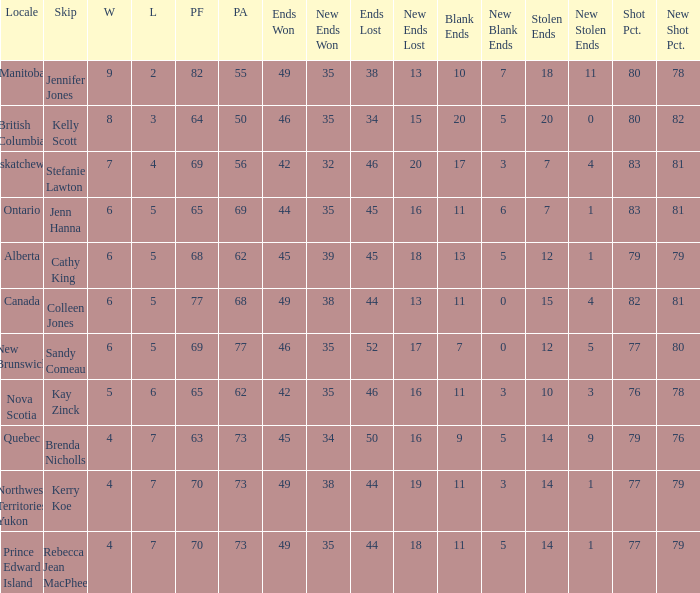What is the lowest PF? 63.0. 